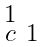Convert formula to latex. <formula><loc_0><loc_0><loc_500><loc_500>\begin{smallmatrix} 1 & \\ c & 1 \end{smallmatrix}</formula> 